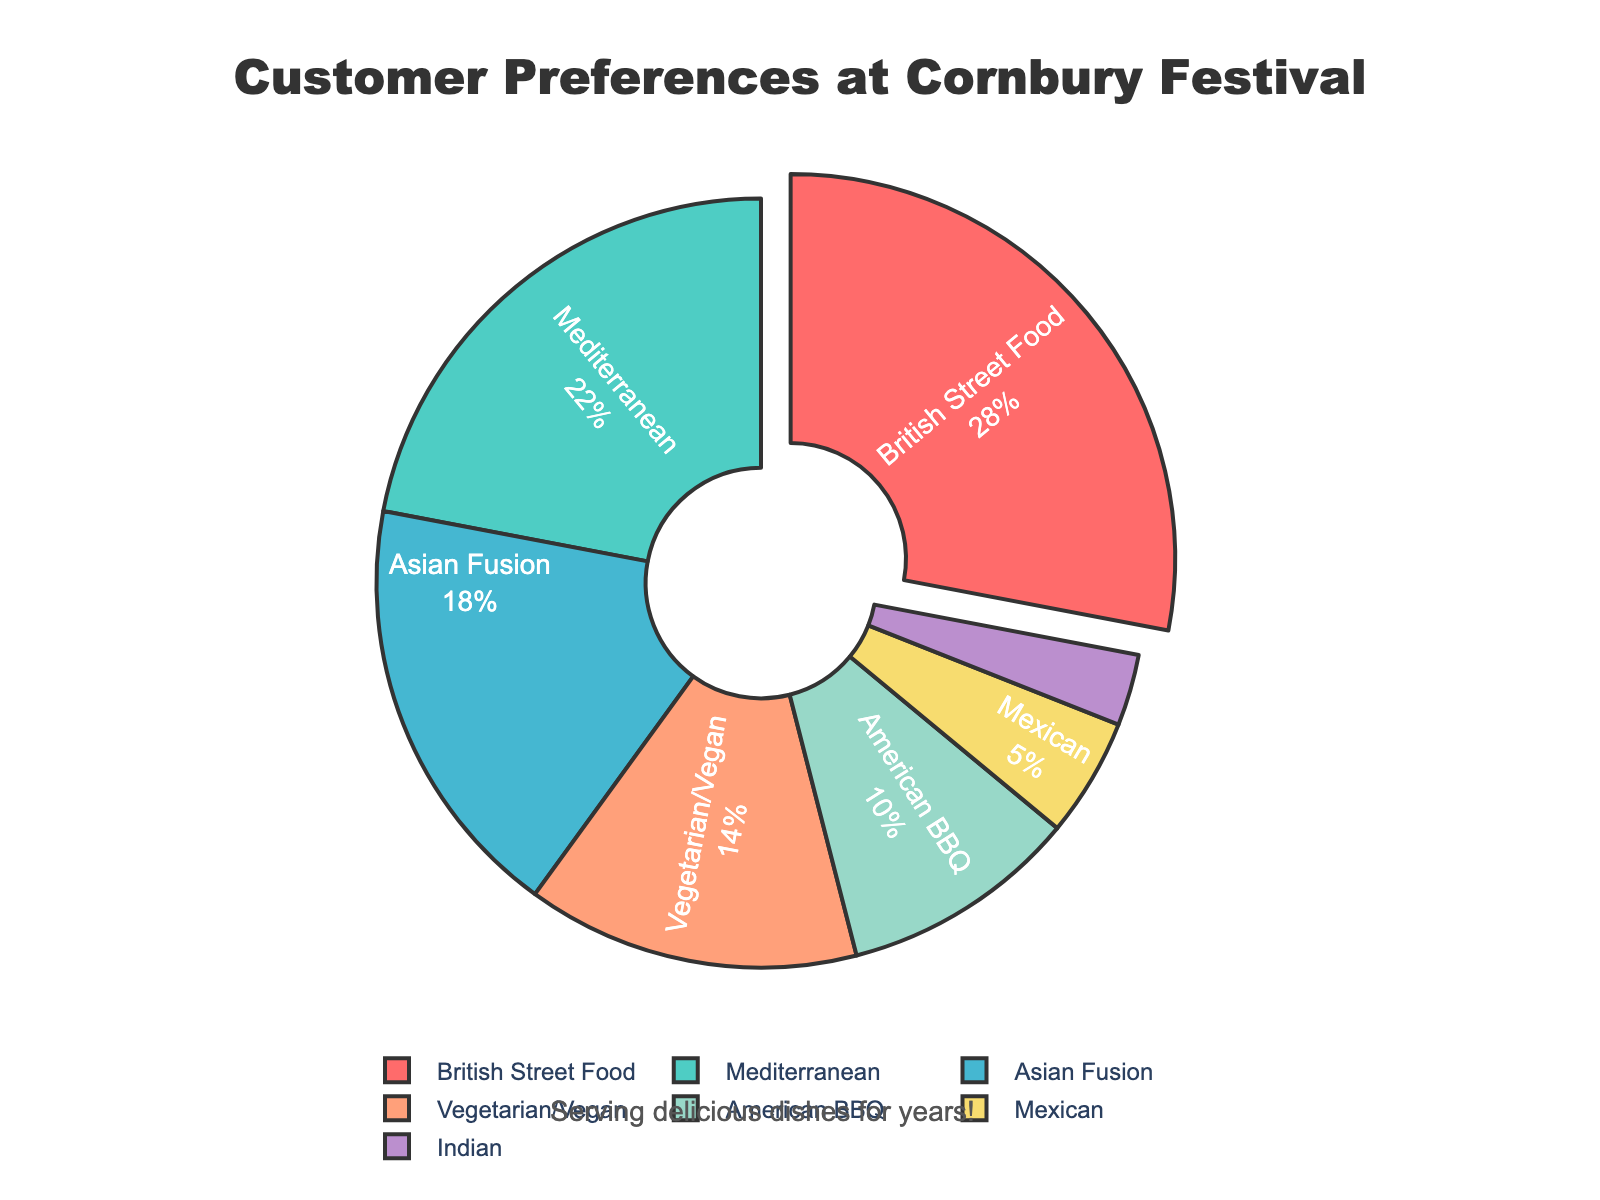What percentage of customers prefer Asian Fusion cuisine? The pie chart shows the percentage distribution of customer preferences for different cuisine types. By locating the label for Asian Fusion, we can see its percentage.
Answer: 18% Which cuisine type is the most preferred by customers at Cornbury Festival? To determine the most preferred cuisine, we look for the largest segment in the pie chart. The largest segment corresponds to British Street Food.
Answer: British Street Food How much more popular is Vegetarian/Vegan cuisine compared to Mexican cuisine? The percentages for Vegetarian/Vegan and Mexican cuisines are 14% and 5%, respectively. To find how much more popular Vegetarian/Vegan is, we calculate the difference: 14% - 5% = 9%.
Answer: 9% What is the combined percentage of customers who prefer British Street Food and Mediterranean cuisines? The percentages for British Street Food and Mediterranean are 28% and 22%, respectively. Adding these gives us the combined percentage: 28% + 22% = 50%.
Answer: 50% Which cuisine type has the lowest customer preference, and what is its percentage? By identifying the smallest segment in the pie chart, we can see that Indian cuisine has the lowest customer preference. The percentage for Indian cuisine is 3%.
Answer: Indian, 3% How does the preference for American BBQ compare to Mediterranean cuisine? The pie chart shows that American BBQ has a preference of 10%, while Mediterranean has 22%. Thus, Mediterranean cuisine is more popular than American BBQ by a difference of 22% - 10% = 12%.
Answer: Mediterranean is 12% more popular What are the three least preferred cuisine types and their respective percentages? The three smallest segments in the pie chart represent the least preferred cuisine types: Indian (3%), Mexican (5%), and American BBQ (10%).
Answer: Indian: 3%, Mexican: 5%, American BBQ: 10% What percentage of customer preferences does Vegetarian/Vegan and American BBQ cuisines together represent? Adding the percentages of Vegetarian/Vegan (14%) and American BBQ (10%) cuisines gives us the total: 14% + 10% = 24%.
Answer: 24% If you combine the percentages of all non-British Street Food cuisines, what percentage do you get? Subtract the percentage of British Street Food (28%) from 100% to find the percentage of all other cuisines combined: 100% - 28% = 72%.
Answer: 72% Which section is represented by a red color in the pie chart? By reviewing the visual attributes in the pie chart, we see that the largest segment, which is British Street Food, is represented in red color.
Answer: British Street Food 